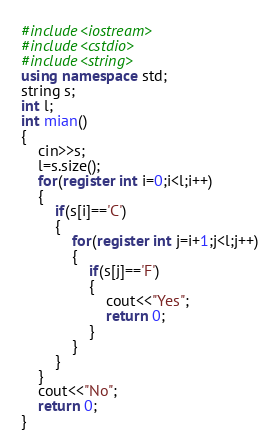<code> <loc_0><loc_0><loc_500><loc_500><_C++_>#include<iostream>
#include<cstdio>
#include<string>
using namespace std;
string s;
int l;
int mian()
{
    cin>>s;
    l=s.size();
    for(register int i=0;i<l;i++)
    {
        if(s[i]=='C')
        {
            for(register int j=i+1;j<l;j++)
            {
                if(s[j]=='F')
                {
                    cout<<"Yes";
                    return 0;
                }
            }
        }
    }
    cout<<"No";
    return 0;
}</code> 